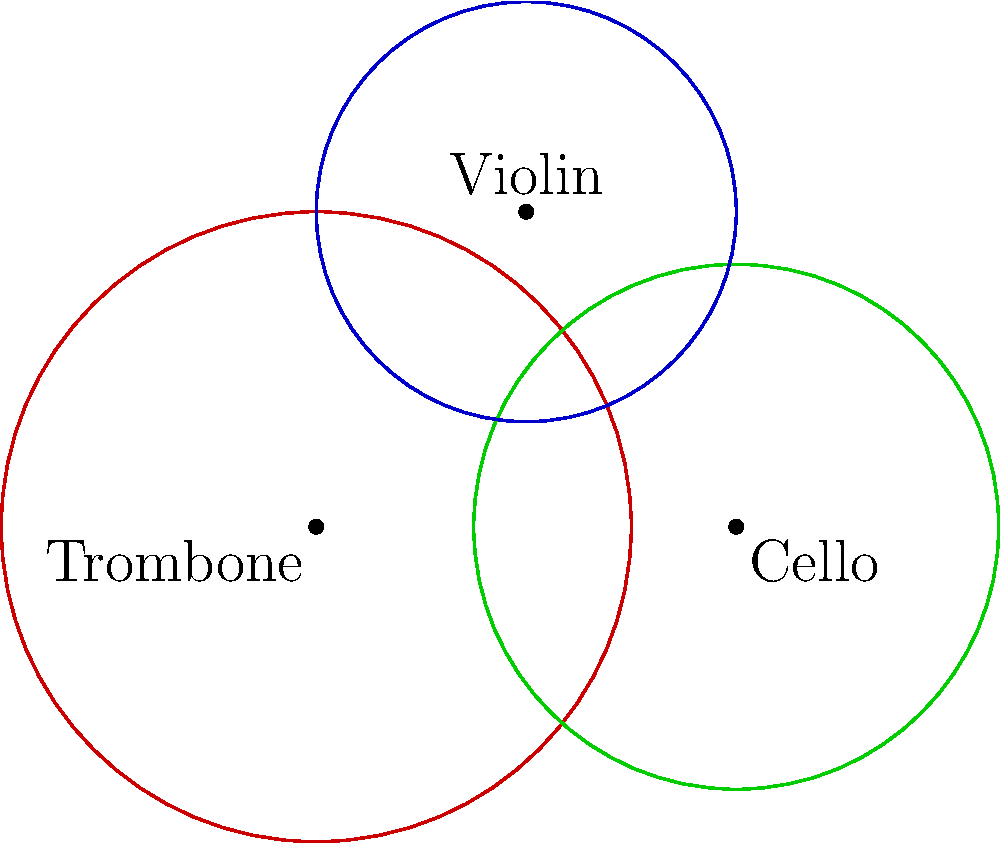In an ASMR video featuring various musical instruments, three circles represent the resonance areas of a trombone, a cello, and a violin. The trombone's resonance circle has a radius of 3 units and is centered at (0,0). The cello's circle has a radius of 2.5 units and is centered at (4,0). The violin's circle has a radius of 2 units and is centered at (2,3). Calculate the total area where at least two instruments' resonances overlap, creating a soothing harmony for ASMR listeners. To solve this problem, we need to follow these steps:

1) First, we need to find the areas of intersection between each pair of circles:
   a) Trombone and Cello
   b) Trombone and Violin
   c) Cello and Violin

2) Then, we need to find the area where all three circles intersect.

3) Finally, we'll use the principle of inclusion-exclusion to calculate the total area of overlap.

Let's start:

1a) Area of intersection between Trombone and Cello:
    Distance between centers = 4
    Radii: 3 and 2.5
    Using the formula for the area of intersection of two circles:
    $$A = r_1^2 \arccos(\frac{d^2 + r_1^2 - r_2^2}{2dr_1}) + r_2^2 \arccos(\frac{d^2 + r_2^2 - r_1^2}{2dr_2}) - \frac{1}{2}\sqrt{(-d+r_1+r_2)(d+r_1-r_2)(d-r_1+r_2)(d+r_1+r_2)}$$
    We get: $A_{TC} \approx 2.7216$ square units

1b) Area of intersection between Trombone and Violin:
    Distance between centers = $\sqrt{2^2 + 3^2} = \sqrt{13}$
    Radii: 3 and 2
    Using the same formula, we get: $A_{TV} \approx 0.6400$ square units

1c) Area of intersection between Cello and Violin:
    Distance between centers = $\sqrt{2^2 + 3^2} = \sqrt{13}$
    Radii: 2.5 and 2
    Using the same formula, we get: $A_{CV} \approx 0.2930$ square units

2) Area where all three circles intersect:
   This area is negligibly small and can be approximated as 0.

3) Using the principle of inclusion-exclusion:
   Total area of overlap = $A_{TC} + A_{TV} + A_{CV} - 2 * A_{all}$
                         $\approx 2.7216 + 0.6400 + 0.2930 - 2 * 0$
                         $\approx 3.6546$ square units

Therefore, the total area where at least two instruments' resonances overlap is approximately 3.6546 square units.
Answer: 3.6546 square units 